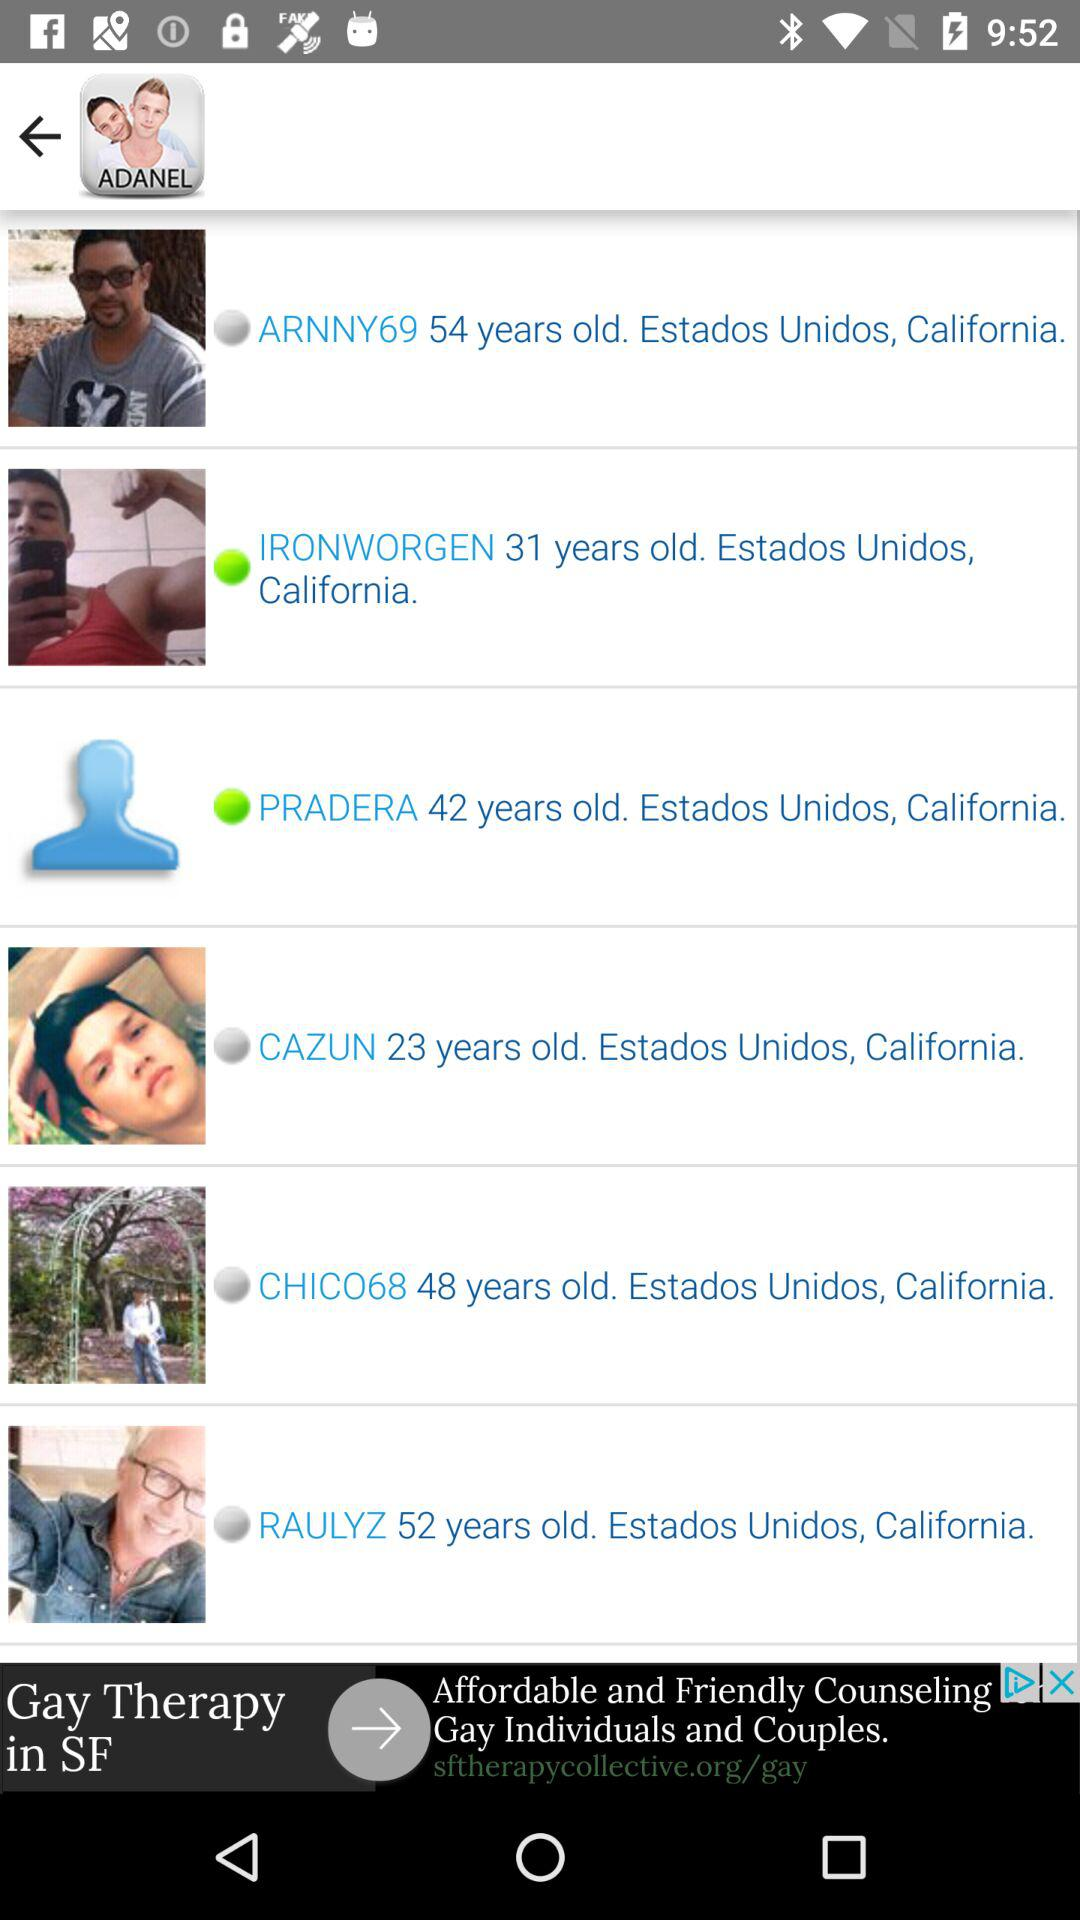Which user is online? The online users are "IRONWORGEN" and "PRADERA". 